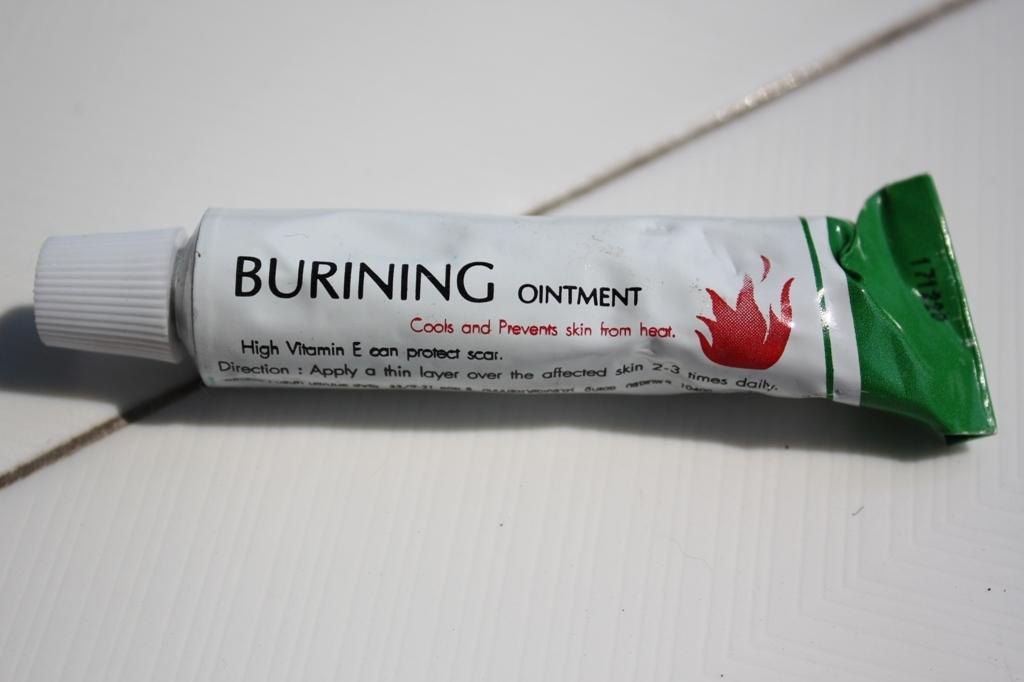What is the main object in the image? There is an ointment tube in the image. Where is the ointment tube located? The ointment tube is on a board. What can be found on the ointment tube? There is text on the ointment tube. How many books are stacked next to the ointment tube in the image? There are no books present in the image. What type of corn is growing in the background of the image? There is no corn visible in the image. 